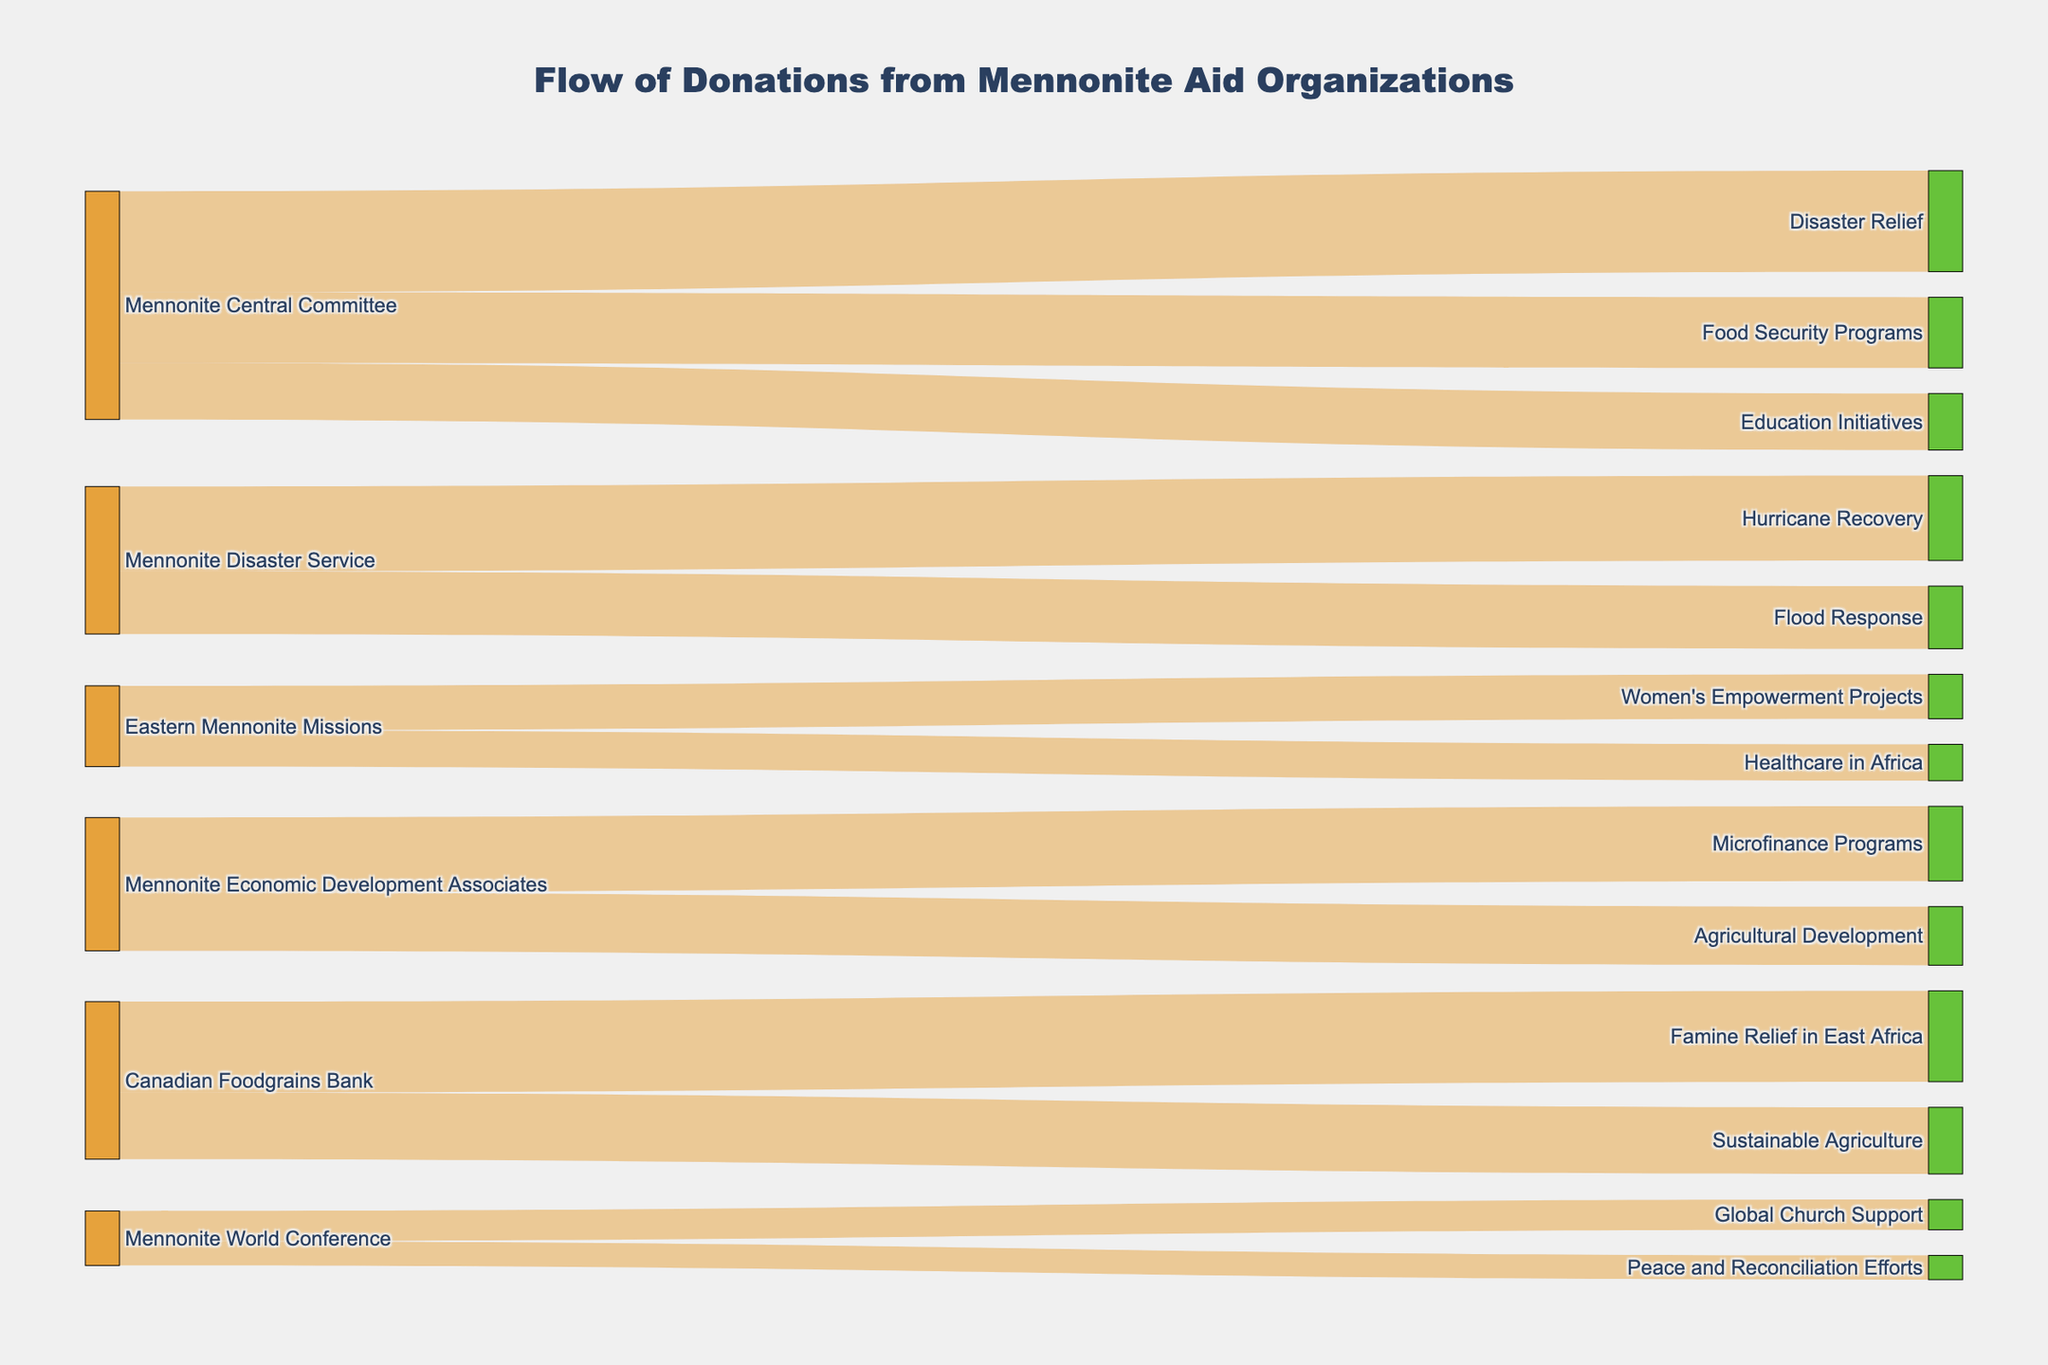What is the largest donation amount from Mennonite Central Committee to a single cause? Identify the largest value associated with Mennonite Central Committee's donations by scanning the diagram for the highest number.
Answer: $5,000,000 Which cause receives the least funding from Mennonite World Conference? Look at the donations made by Mennonite World Conference, and identify the smaller value between Global Church Support and Peace and Reconciliation Efforts.
Answer: Peace and Reconciliation Efforts How much total funding is allocated to Disaster Relief by Mennonite Central Committee and Mennonite Disaster Service together? Sum the contributions to Disaster Relief from both organizations: $5,000,000 from Mennonite Central Committee and $4,200,000 (Hurricane Recovery) + $3,100,000 (Flood Response) from Mennonite Disaster Service.
Answer: $12,300,000 Which source organization provides the most funding for Women's Empowerment Projects? Check the labels for Women's Empowerment Projects and look for the largest donation amount.
Answer: Eastern Mennonite Missions Are Food Security Programs funded by more than one organization? Look at the connections targeting Food Security Programs and check if more than one source organization is linked.
Answer: No How much more funding does the Mennonite Central Committee give to Disaster Relief compared to Education Initiatives? Subtract the funding amounts for Education Initiatives from Disaster Relief by Mennonite Central Committee: $5,000,000 - $2,800,000.
Answer: $2,200,000 What is the total funding provided by the Mennonite Economic Development Associates? Sum the donations given to both Microfinance Programs and Agricultural Development: $3,700,000 + $2,900,000.
Answer: $6,600,000 Which cause receives the highest number of different donations? Identify which target receives contributions from the highest number of different organizations by counting their sources.
Answer: Disaster Relief (including both Hurricane Recovery and Flood Response) What proportion of the total donation from Mennonite Central Committee goes to Food Security Programs? Divide the Food Security Programs donation by the total contributions from Mennonite Central Committee and express it as a percentage: ($3,500,000 / ($5,000,000 + $3,500,000 + $2,800,000)) * 100%.
Answer: 28% How much more does the Canadian Foodgrains Bank allocate to Famine Relief in East Africa compared to Sustainable Agriculture? Subtract the donation amount for Sustainable Agriculture from Famine Relief in East Africa: $4,500,000 - $3,300,000.
Answer: $1,200,000 